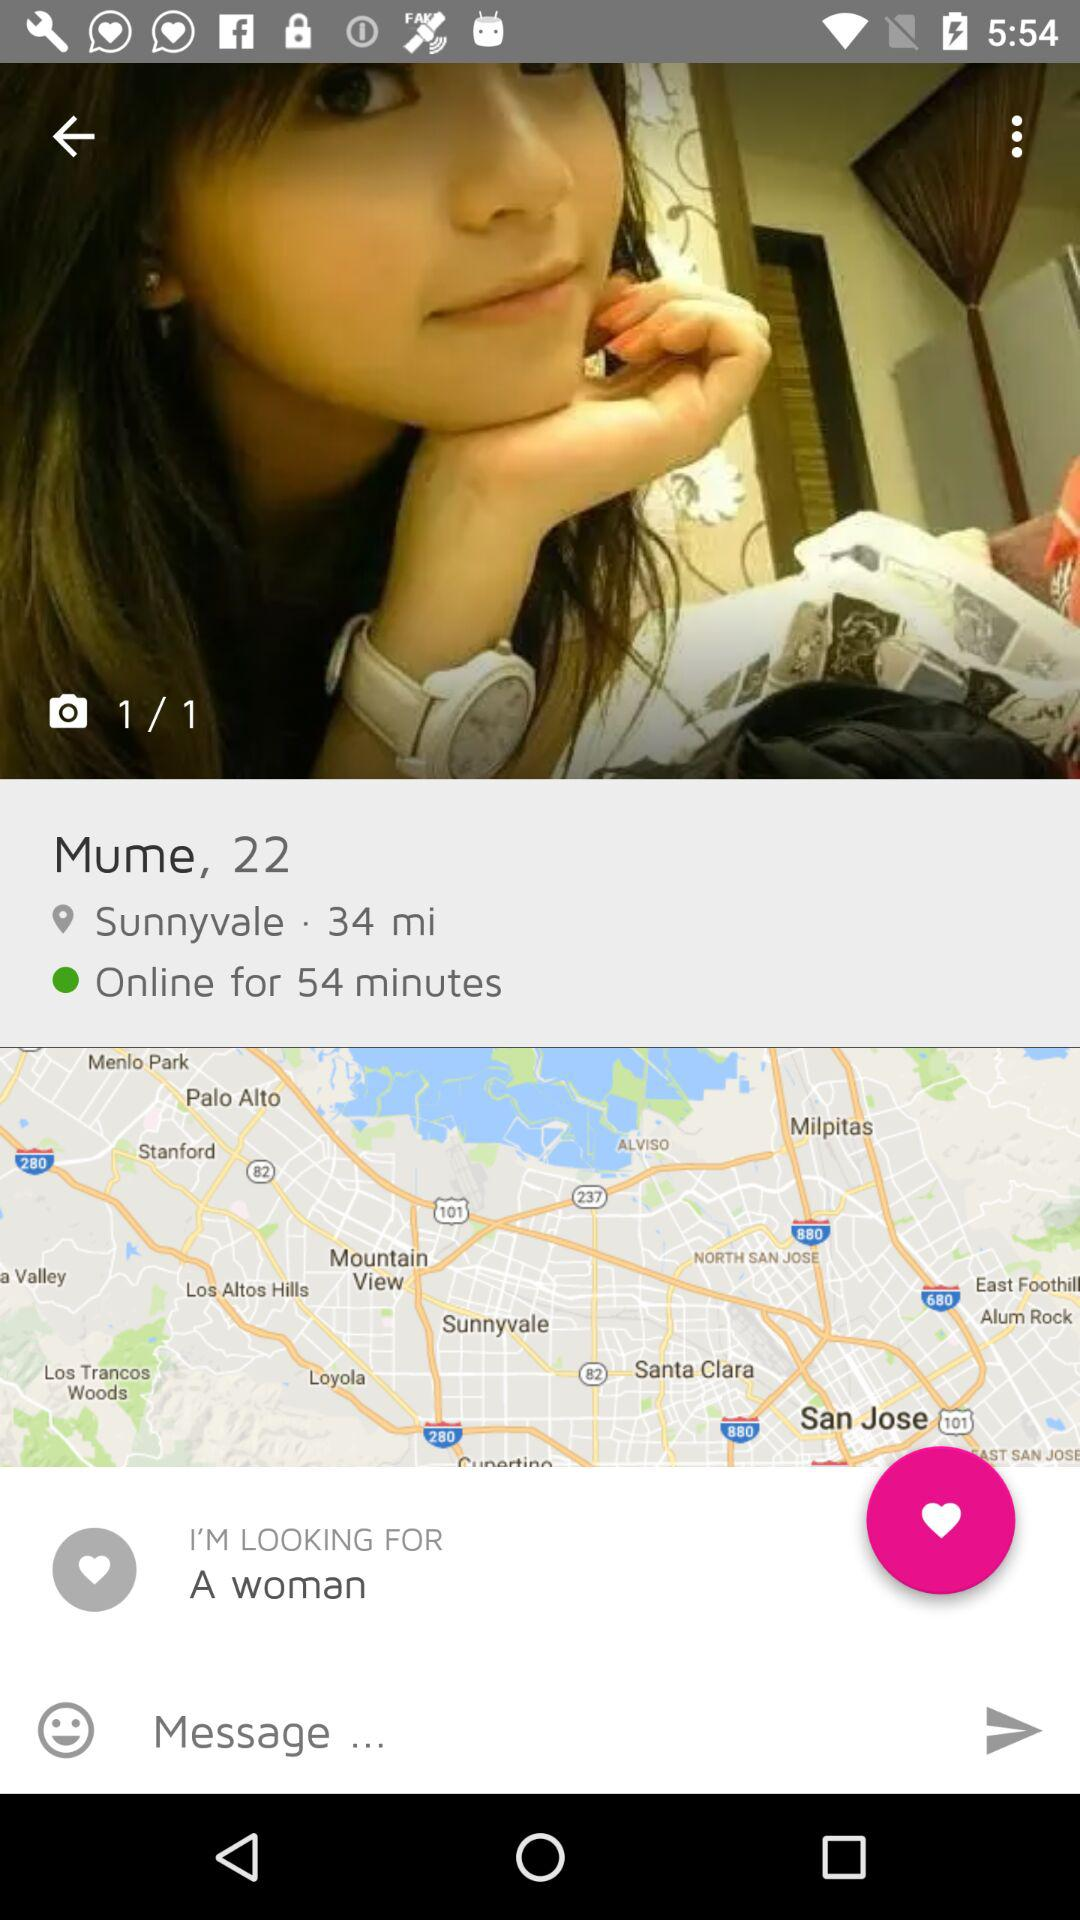What is the location? The location is Sunnyvale. 